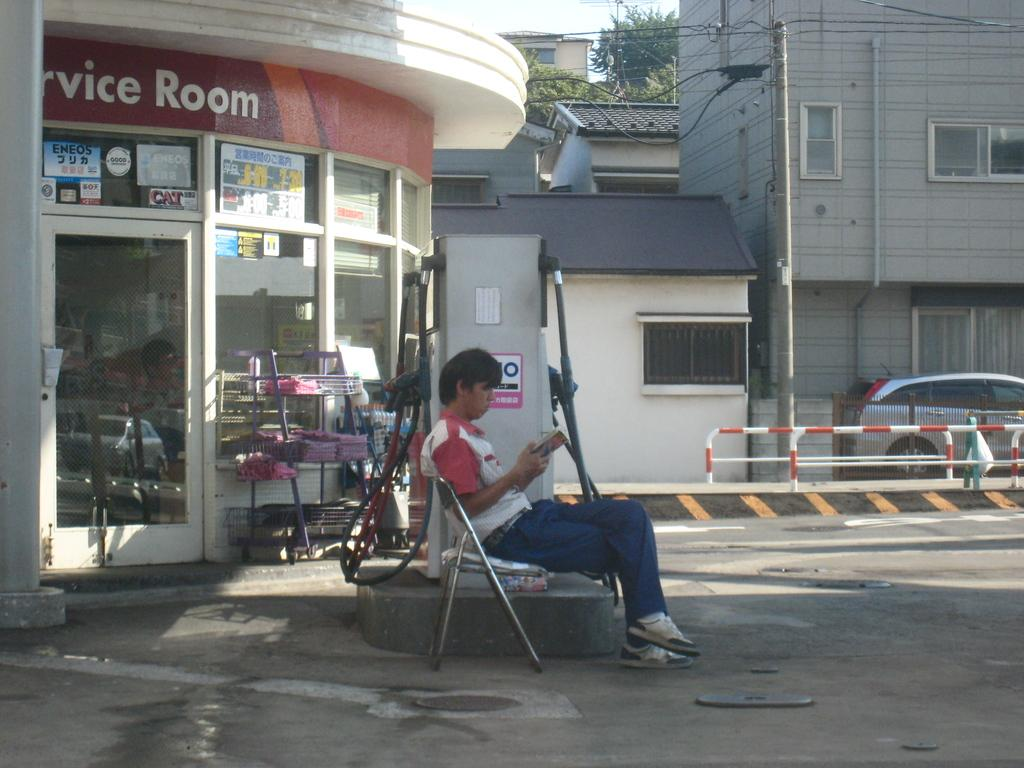What is the person in the image doing? There is a person sitting on a chair in the image. What can be seen in the distance behind the person? There are buildings in the background of the image. What mode of transportation is present in the image? There is a car in the image. What surface is the car and person on? There is a road visible in the image. How much salt is being used in the image? There is no salt present in the image. Is there a camp visible in the image? There is no camp present in the image. 